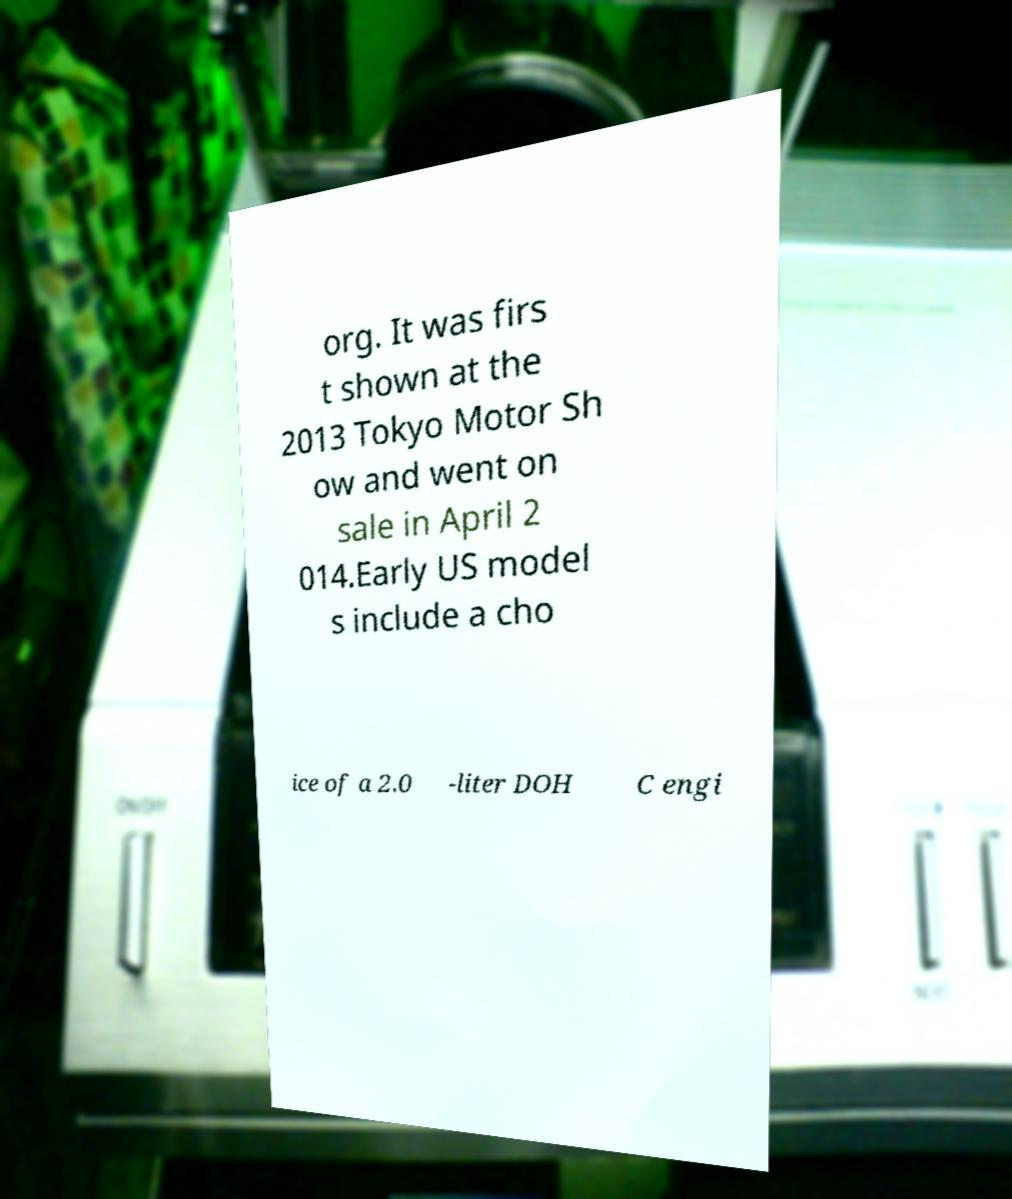What messages or text are displayed in this image? I need them in a readable, typed format. org. It was firs t shown at the 2013 Tokyo Motor Sh ow and went on sale in April 2 014.Early US model s include a cho ice of a 2.0 -liter DOH C engi 